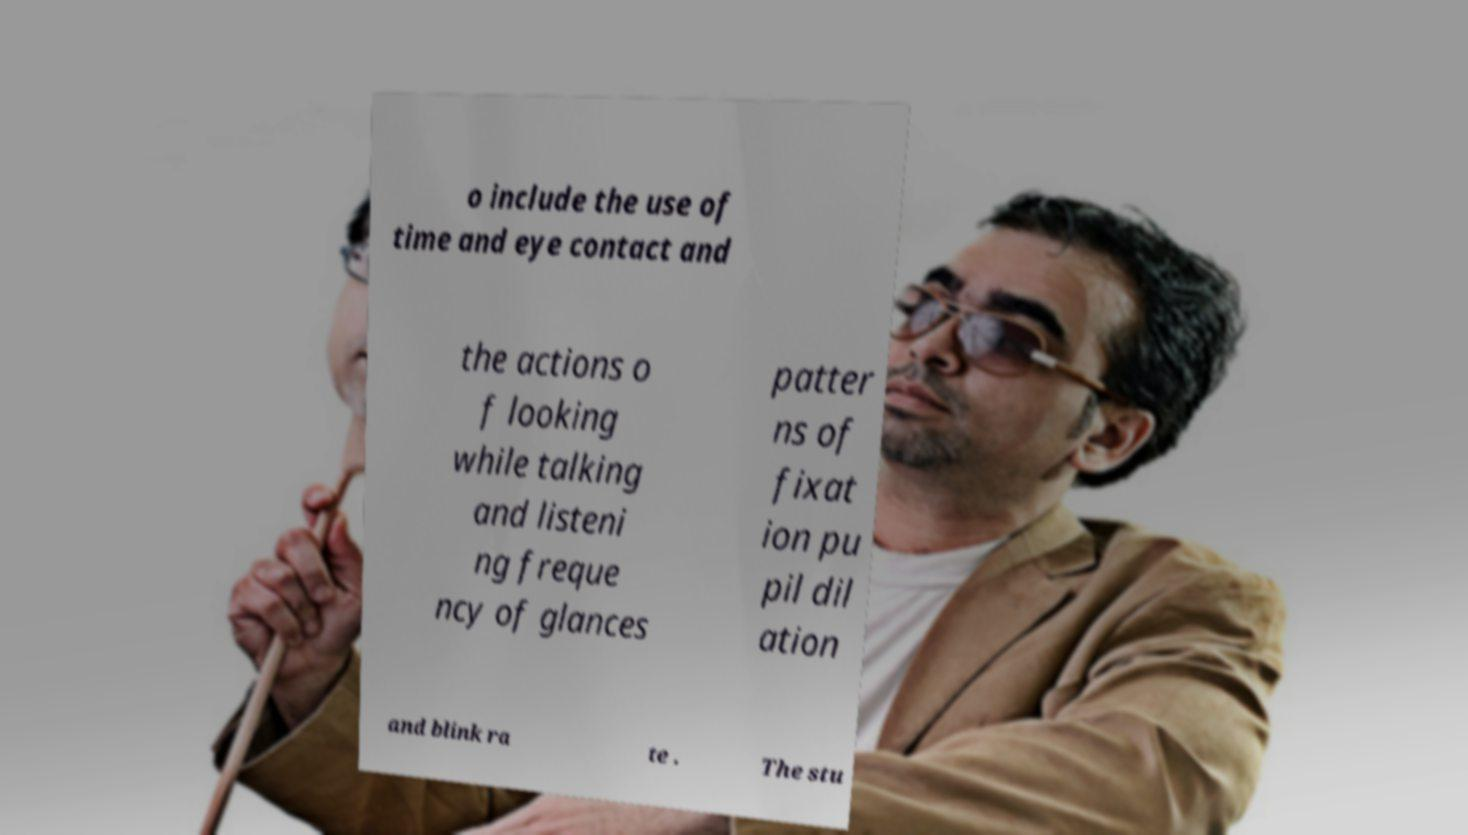What messages or text are displayed in this image? I need them in a readable, typed format. o include the use of time and eye contact and the actions o f looking while talking and listeni ng freque ncy of glances patter ns of fixat ion pu pil dil ation and blink ra te . The stu 